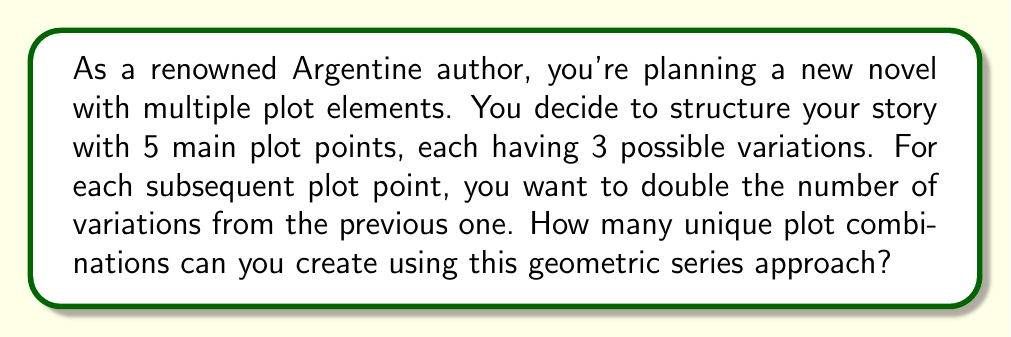Give your solution to this math problem. Let's approach this step-by-step:

1) We start with 5 plot points, each following a geometric series.
2) The first plot point has 3 variations.
3) Each subsequent plot point doubles the variations of the previous one.

Let's list out the number of variations for each plot point:
- Plot point 1: 3 variations
- Plot point 2: $3 \times 2 = 6$ variations
- Plot point 3: $6 \times 2 = 12$ variations
- Plot point 4: $12 \times 2 = 24$ variations
- Plot point 5: $24 \times 2 = 48$ variations

This forms a geometric sequence with 5 terms: 3, 6, 12, 24, 48

To find the total number of unique plot combinations, we need to multiply these numbers:

$$ \text{Total combinations} = 3 \times 6 \times 12 \times 24 \times 48 $$

We can simplify this:
$$ \begin{align}
\text{Total combinations} &= 3 \times 6 \times 12 \times 24 \times 48 \\
&= 3 \times (3 \times 2) \times (3 \times 2^2) \times (3 \times 2^3) \times (3 \times 2^4) \\
&= 3^5 \times 2^{0+1+2+3+4} \\
&= 243 \times 2^{10} \\
&= 243 \times 1024 \\
&= 248,832
\end{align} $$

Therefore, the total number of unique plot combinations is 248,832.
Answer: 248,832 combinations 